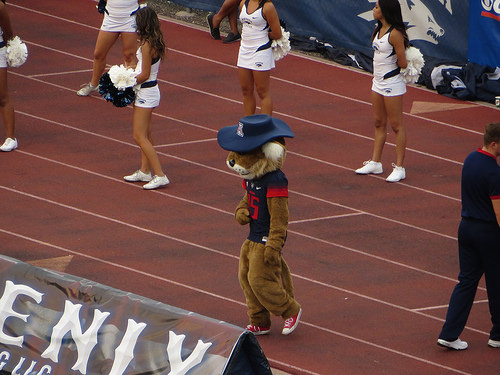<image>
Can you confirm if the mascot is on the cheerleader? No. The mascot is not positioned on the cheerleader. They may be near each other, but the mascot is not supported by or resting on top of the cheerleader. 